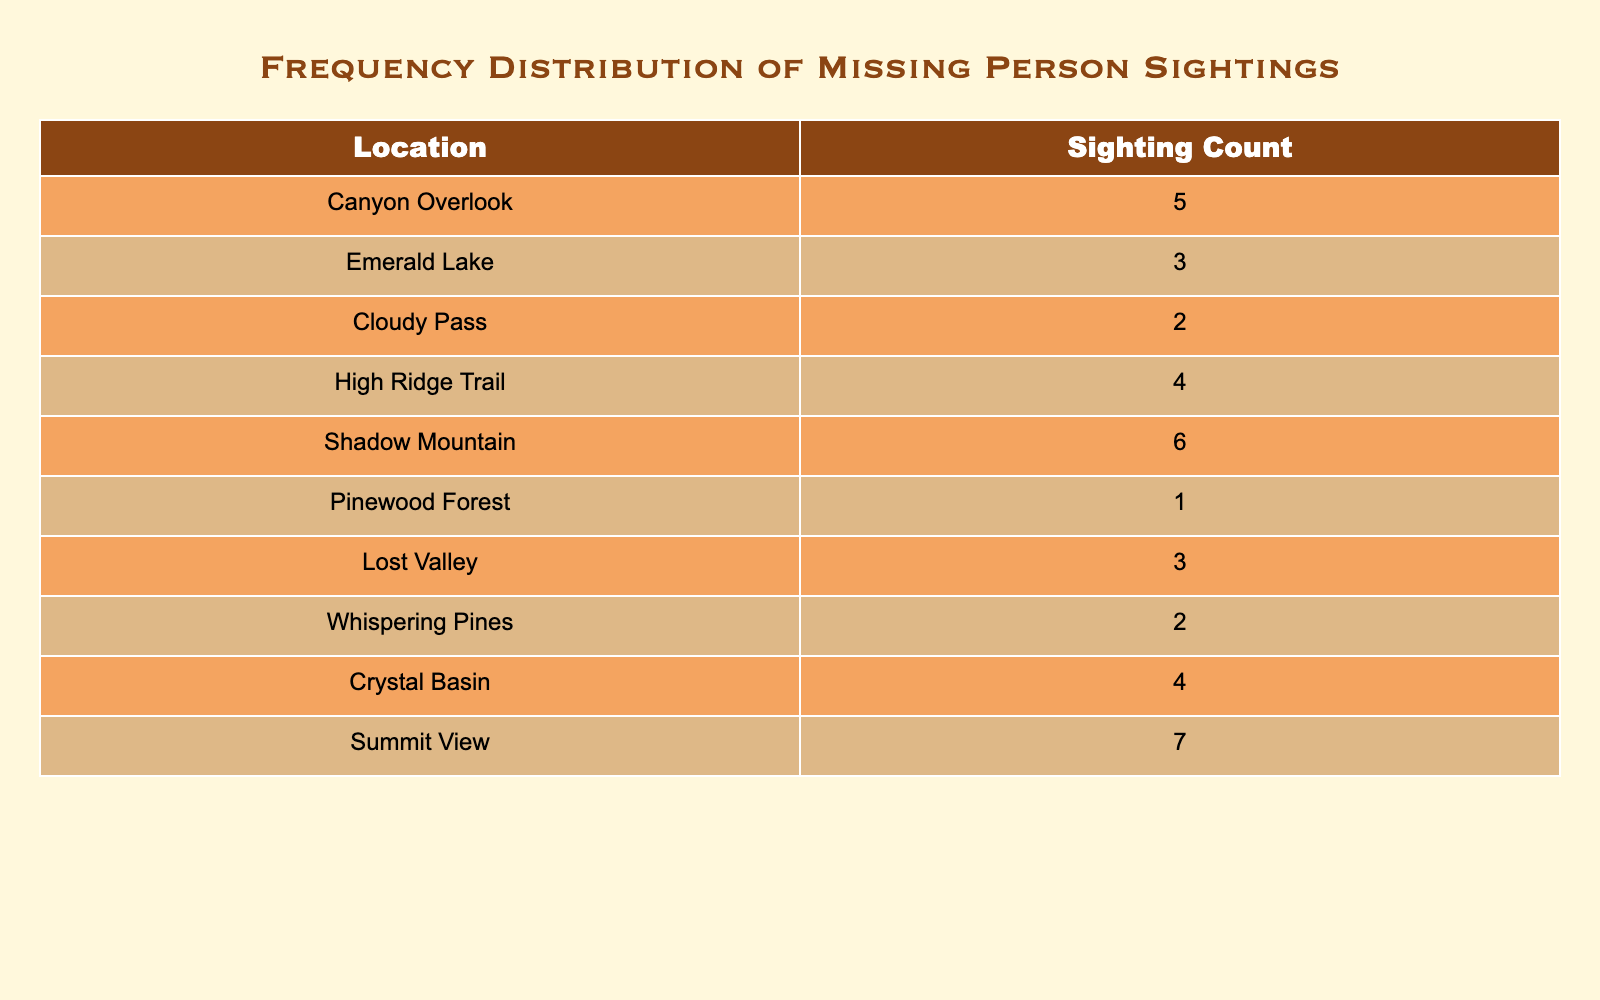What location has the highest number of sightings? By examining the 'Sighting Count' column, we can identify that "Summit View" has the highest value of 7, which is greater than the counts for all other locations.
Answer: Summit View How many total sightings were reported across all locations? To find the total sightings, we add the 'Sighting Count' for all locations: 5 + 3 + 2 + 4 + 6 + 1 + 3 + 2 + 4 + 7 = 37.
Answer: 37 Are there more sightings at "Canyon Overlook" than at "Lost Valley"? The 'Sighting Count' for "Canyon Overlook" is 5, while for "Lost Valley" it is 3. Since 5 is greater than 3, the answer is yes.
Answer: Yes What is the average number of sightings across all locations? First, we need the total sightings, which we found to be 37. There are 10 locations, so the average is calculated by dividing the total sightings by the number of locations: 37 / 10 = 3.7.
Answer: 3.7 Which location has the least number of sightings? By looking at the 'Sighting Count', we can see "Pinewood Forest" with a count of 1, which is the lowest among all locations.
Answer: Pinewood Forest How many sightings were reported for locations that had sightings greater than 3? The locations with sightings greater than 3 are: "Canyon Overlook" (5), "High Ridge Trail" (4), "Shadow Mountain" (6), "Crystal Basin" (4), and "Summit View" (7). Summing these gives us 5 + 4 + 6 + 4 + 7 = 26.
Answer: 26 Is the number of sightings at "Emerald Lake" equal to the number at "Whispering Pines"? The counts are 3 for "Emerald Lake" and 2 for "Whispering Pines". Since 3 is not equal to 2, the answer is no.
Answer: No What is the difference between the highest and lowest sightings? The highest sightings are at "Summit View" with 7, and the lowest is "Pinewood Forest" with 1. The difference is calculated as 7 - 1 = 6.
Answer: 6 